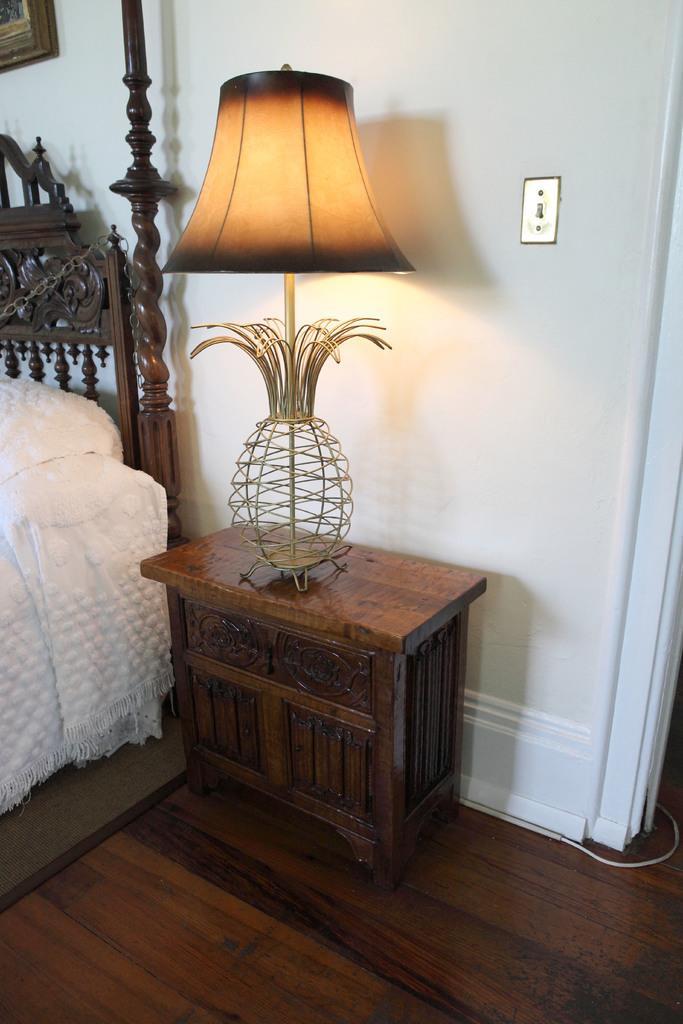Please provide a concise description of this image. In this picture we can see a table on the floor with a lamp on it, bed and a frame on the wall. 